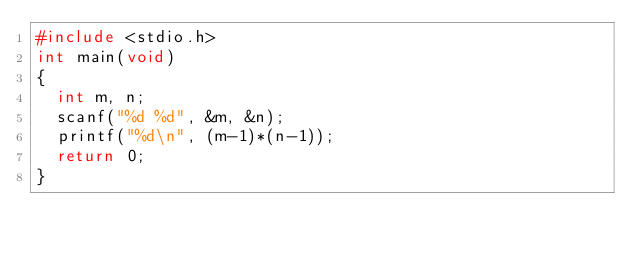Convert code to text. <code><loc_0><loc_0><loc_500><loc_500><_C_>#include <stdio.h>
int main(void)
{
  int m, n;
  scanf("%d %d", &m, &n);
  printf("%d\n", (m-1)*(n-1));
  return 0;
}
</code> 